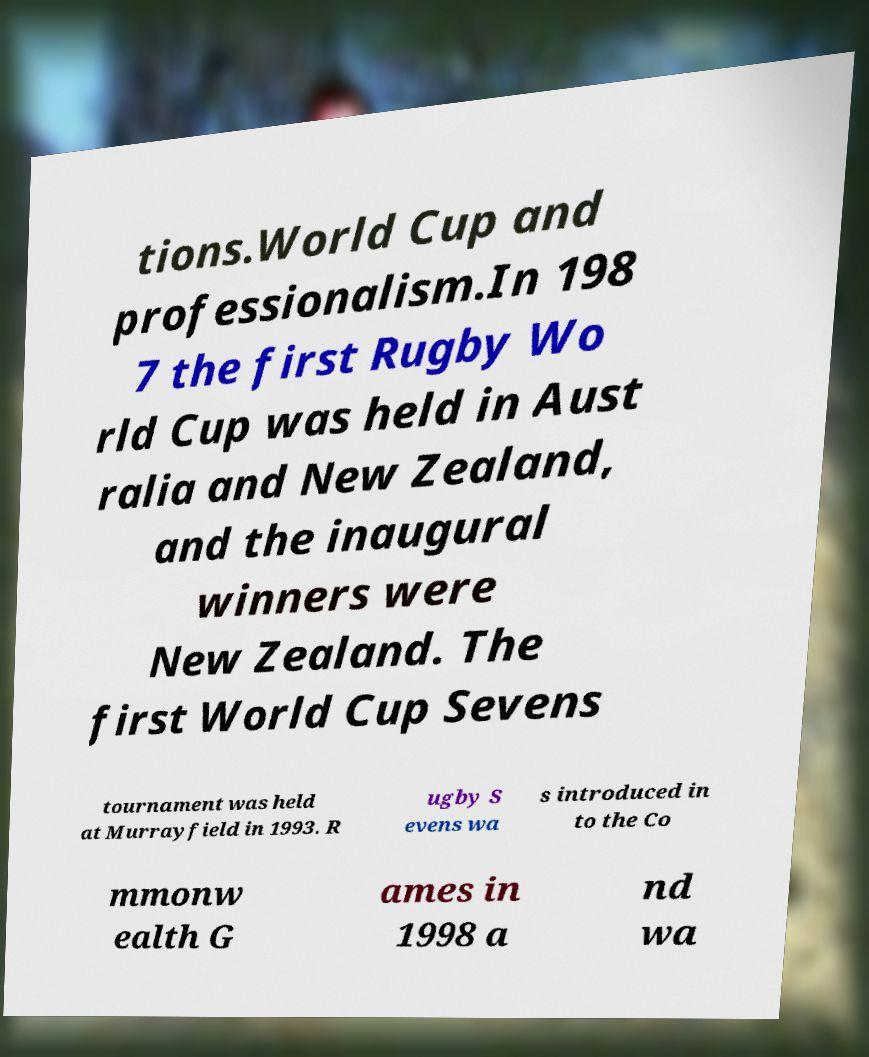Please identify and transcribe the text found in this image. tions.World Cup and professionalism.In 198 7 the first Rugby Wo rld Cup was held in Aust ralia and New Zealand, and the inaugural winners were New Zealand. The first World Cup Sevens tournament was held at Murrayfield in 1993. R ugby S evens wa s introduced in to the Co mmonw ealth G ames in 1998 a nd wa 